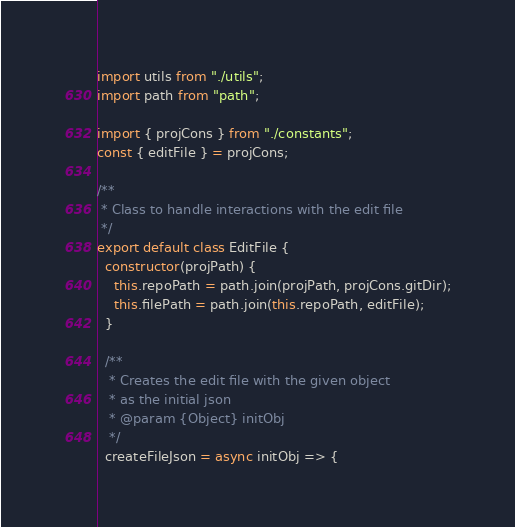Convert code to text. <code><loc_0><loc_0><loc_500><loc_500><_JavaScript_>import utils from "./utils";
import path from "path";

import { projCons } from "./constants";
const { editFile } = projCons;

/**
 * Class to handle interactions with the edit file
 */
export default class EditFile {
  constructor(projPath) {
    this.repoPath = path.join(projPath, projCons.gitDir);
    this.filePath = path.join(this.repoPath, editFile);
  }

  /**
   * Creates the edit file with the given object
   * as the initial json
   * @param {Object} initObj
   */
  createFileJson = async initObj => {</code> 